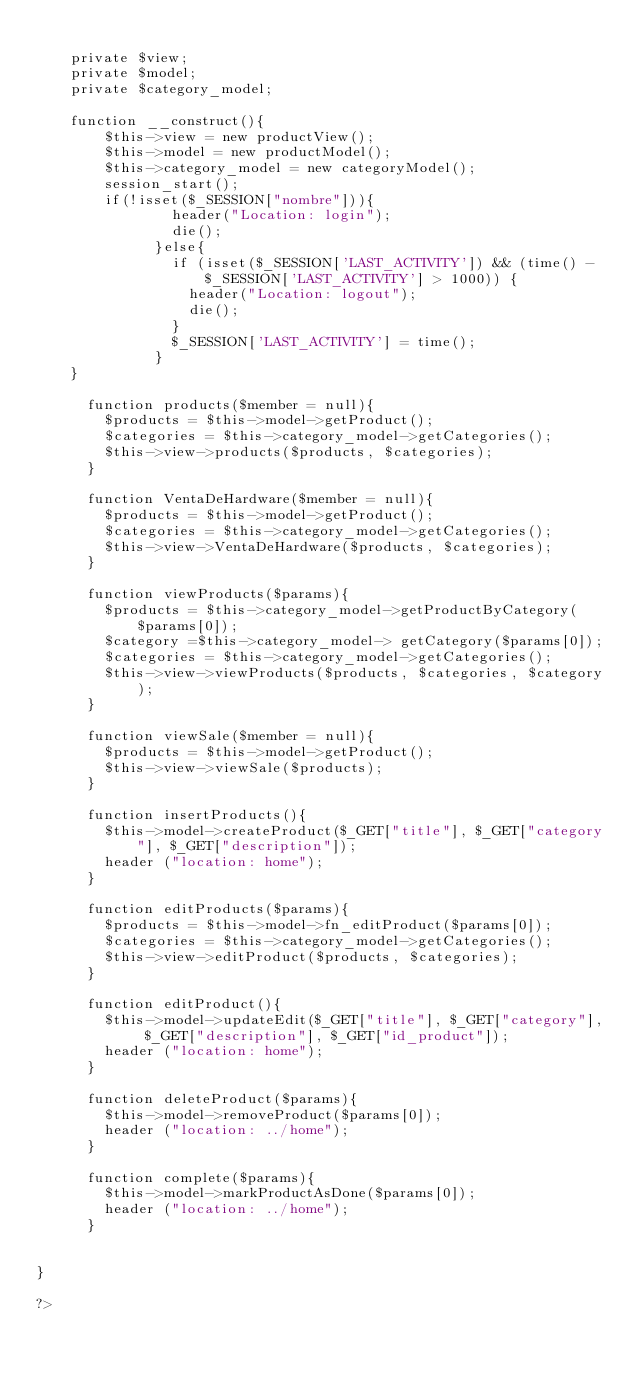Convert code to text. <code><loc_0><loc_0><loc_500><loc_500><_PHP_>
    private $view;
    private $model;
    private $category_model;

    function __construct(){
        $this->view = new productView();
        $this->model = new productModel();
        $this->category_model = new categoryModel();
        session_start();
        if(!isset($_SESSION["nombre"])){ 
                header("Location: login");
                die();
              }else{ 
                if (isset($_SESSION['LAST_ACTIVITY']) && (time() - $_SESSION['LAST_ACTIVITY'] > 1000)) { 
                  header("Location: logout");
                  die();
                } 
                $_SESSION['LAST_ACTIVITY'] = time();
              }
    }
    
      function products($member = null){
        $products = $this->model->getProduct();
        $categories = $this->category_model->getCategories();
        $this->view->products($products, $categories);
      }

      function VentaDeHardware($member = null){
        $products = $this->model->getProduct();
        $categories = $this->category_model->getCategories();
        $this->view->VentaDeHardware($products, $categories);
      }
      
      function viewProducts($params){
        $products = $this->category_model->getProductByCategory($params[0]);
        $category =$this->category_model-> getCategory($params[0]);
        $categories = $this->category_model->getCategories();
        $this->view->viewProducts($products, $categories, $category);
      }
      
      function viewSale($member = null){
        $products = $this->model->getProduct();
        $this->view->viewSale($products);
      }

      function insertProducts(){
        $this->model->createProduct($_GET["title"], $_GET["category"], $_GET["description"]); 
        header ("location: home");
      }

      function editProducts($params){
        $products = $this->model->fn_editProduct($params[0]);
        $categories = $this->category_model->getCategories();
        $this->view->editProduct($products, $categories);
      }

      function editProduct(){
        $this->model->updateEdit($_GET["title"], $_GET["category"], $_GET["description"], $_GET["id_product"]);
        header ("location: home");
      }
      
      function deleteProduct($params){
        $this->model->removeProduct($params[0]); 
        header ("location: ../home");
      }
      
      function complete($params){
        $this->model->markProductAsDone($params[0]);
        header ("location: ../home");
      }
      

}

?></code> 